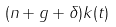Convert formula to latex. <formula><loc_0><loc_0><loc_500><loc_500>( n + g + \delta ) k ( t )</formula> 